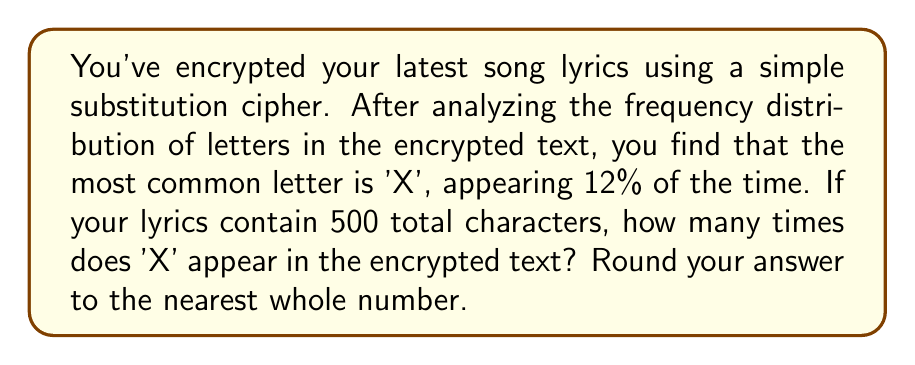Can you answer this question? To solve this problem, we'll follow these steps:

1. Understand the given information:
   * The most common letter in the encrypted text is 'X'
   * 'X' appears 12% of the time
   * The total number of characters in the lyrics is 500

2. Calculate the number of times 'X' appears:
   * Let $n$ be the number of times 'X' appears
   * We can express this as a percentage: $\frac{n}{500} = 12\%$
   * Convert the percentage to a decimal: $12\% = 0.12$
   * Now we have the equation: $\frac{n}{500} = 0.12$

3. Solve for $n$:
   * Multiply both sides by 500: $n = 500 \times 0.12$
   * Calculate: $n = 60$

4. Round to the nearest whole number:
   * 60 is already a whole number, so no rounding is necessary

Therefore, 'X' appears 60 times in the encrypted text.
Answer: 60 